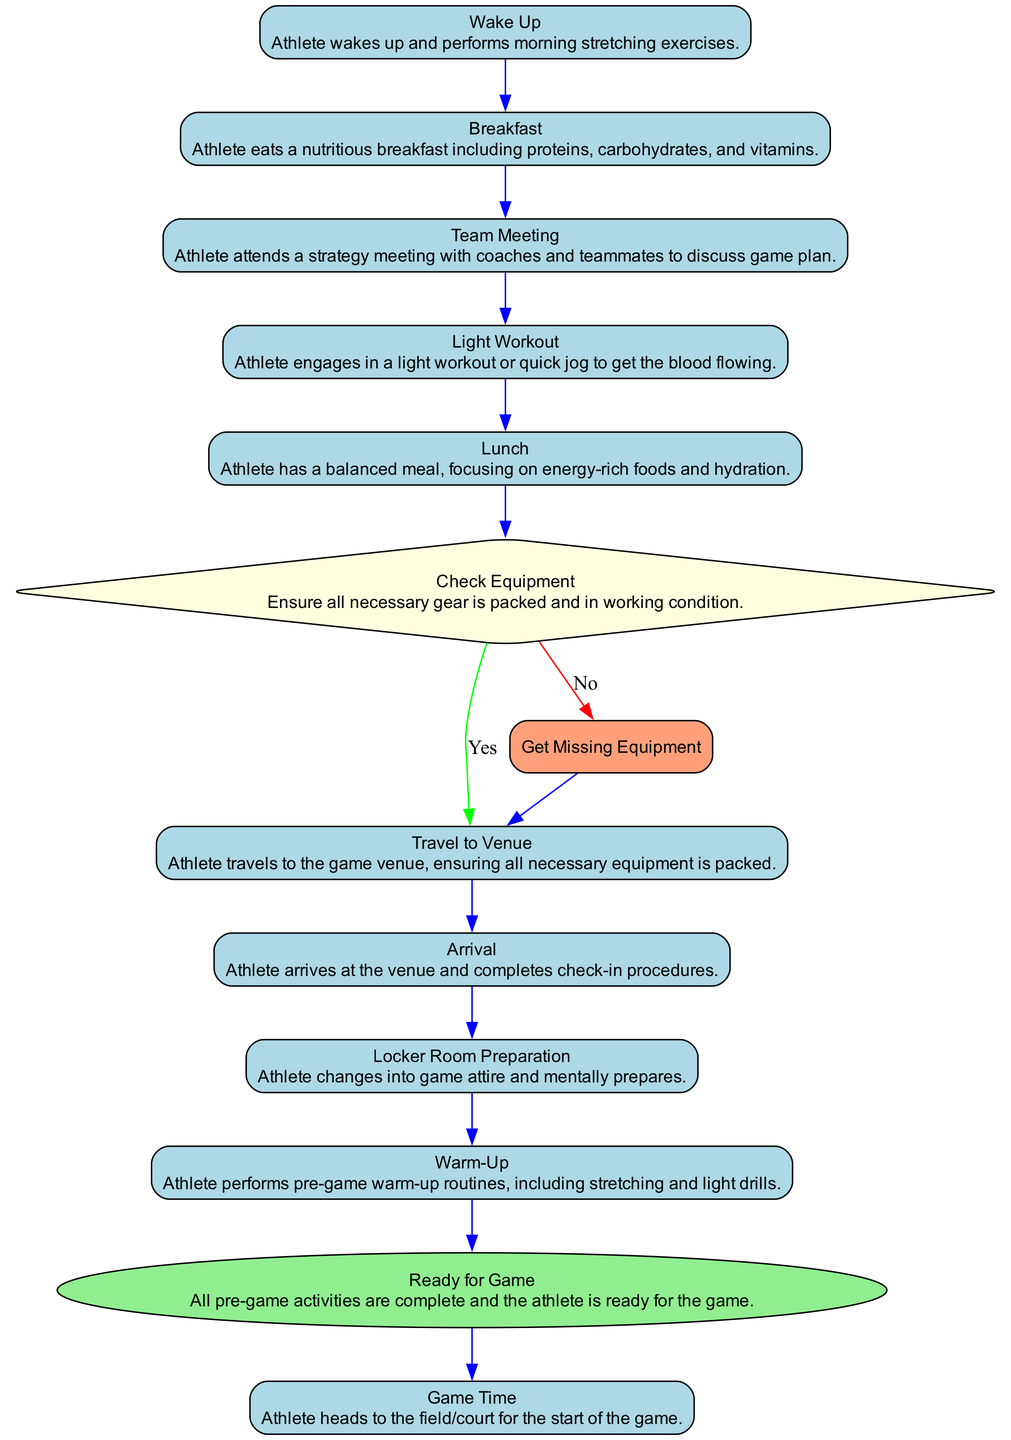What is the first activity in the routine? The first activity listed in the diagram is "Wake Up." It appears at the top of the flow, indicating that it is the starting point of the game day preparation process.
Answer: Wake Up How many activities are there in total? Counting from the details provided, there are ten distinct activities listed in the diagram. This includes all steps from waking up to game time.
Answer: Ten What decision follows the Lunch activity? The decision that follows the Lunch activity is "Check Equipment." This decision is crucial as it determines whether the athlete has everything needed for the game.
Answer: Check Equipment What happens if the equipment check is "No"? If the equipment check is "No," the athlete must "Get Missing Equipment." This leads to acquiring any necessary gear before proceeding to the next step.
Answer: Get Missing Equipment What is the last activity before "Game Time"? The last activity before "Game Time" is "Ready for Game." This merge indicates that all pre-game activities have been completed successfully.
Answer: Ready for Game Which activity involves strategy meetings? The activity that involves strategy meetings is "Team Meeting." In this step, athletes discuss the game plan with coaches and teammates.
Answer: Team Meeting What is the main purpose of the "Warm-Up" activity? The main purpose of the "Warm-Up" activity is to prepare the athlete physically and mentally for the game through stretching and light drills.
Answer: Prepare physically and mentally How do you transition from "Light Workout" to the next activity? The transition from "Light Workout" to the next activity, "Lunch," occurs without any decision or branching, indicating a direct flow from one activity to the next.
Answer: Direct flow In which shape is the "Check Equipment" decision represented? The "Check Equipment" decision is represented in a diamond shape. This shape is standard for decisions in activity diagrams, indicating a branching point.
Answer: Diamond shape 